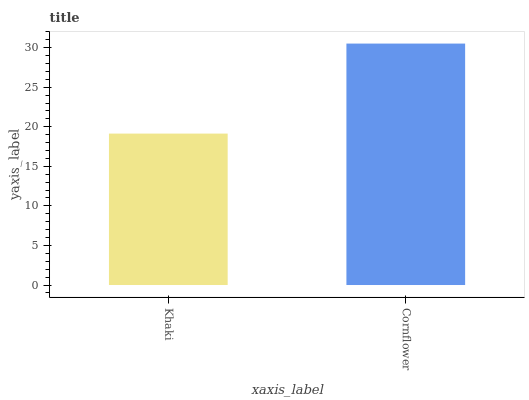Is Khaki the minimum?
Answer yes or no. Yes. Is Cornflower the maximum?
Answer yes or no. Yes. Is Cornflower the minimum?
Answer yes or no. No. Is Cornflower greater than Khaki?
Answer yes or no. Yes. Is Khaki less than Cornflower?
Answer yes or no. Yes. Is Khaki greater than Cornflower?
Answer yes or no. No. Is Cornflower less than Khaki?
Answer yes or no. No. Is Cornflower the high median?
Answer yes or no. Yes. Is Khaki the low median?
Answer yes or no. Yes. Is Khaki the high median?
Answer yes or no. No. Is Cornflower the low median?
Answer yes or no. No. 